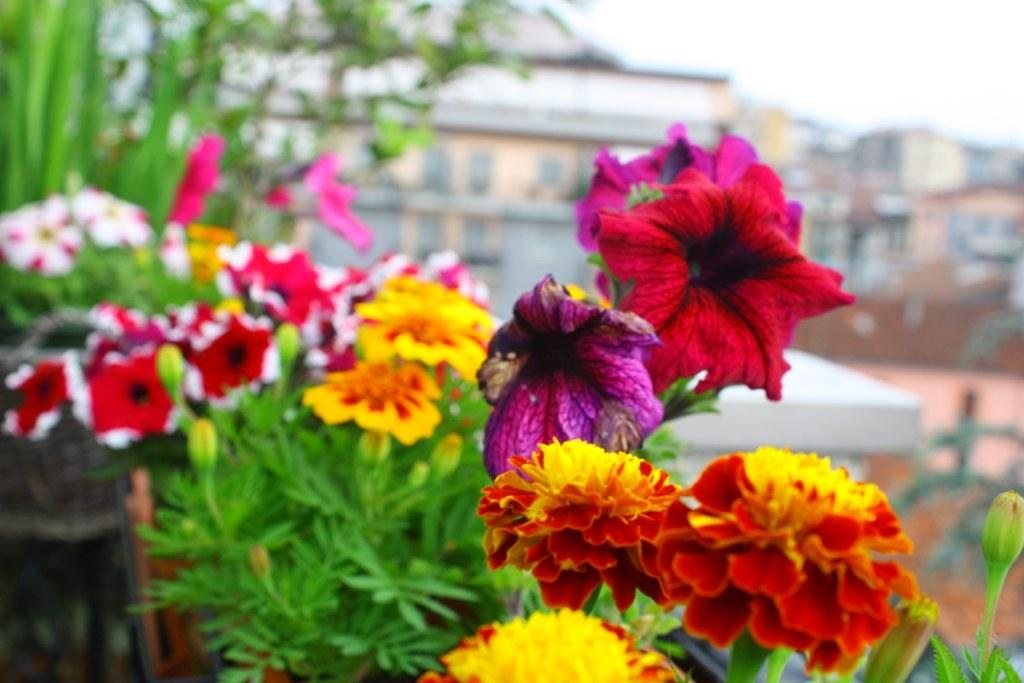What type of plants can be seen in the image? There are flowers in the image. What stage of growth are the plants in? There are buds on the plants in the image. What can be seen in the distance behind the plants? There are buildings visible in the background of the image. How is the background view depicted in the image? The background view is blurred. What type of cream can be seen dripping from the quartz in the image? There is no cream or quartz present in the image. How many bells are hanging from the flowers in the image? There are no bells present in the image; it features flowers and plants. 